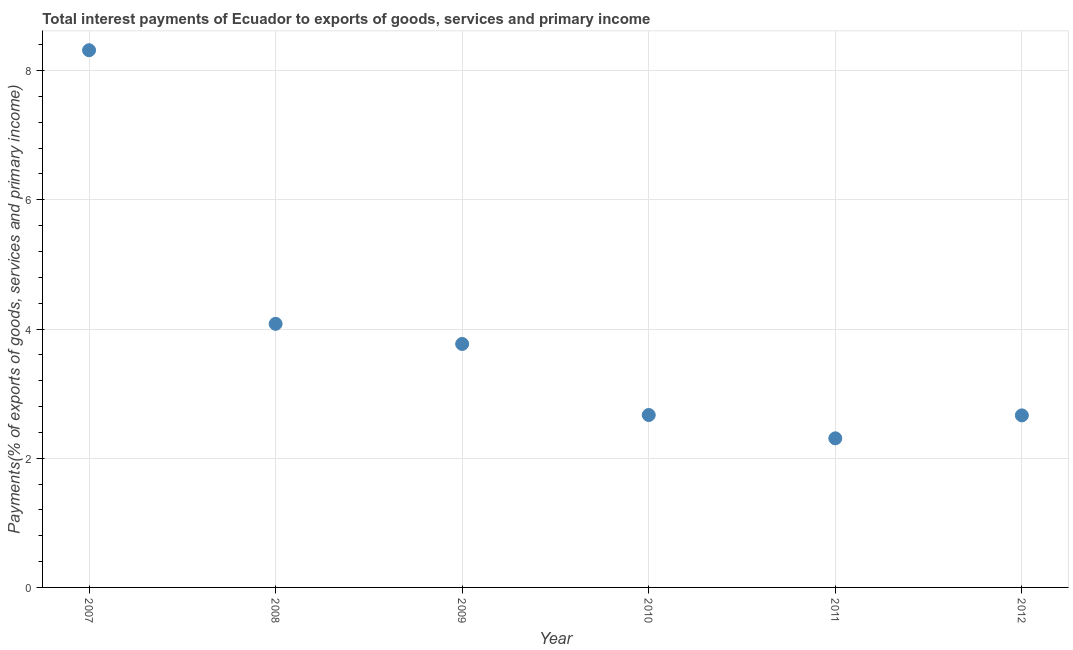What is the total interest payments on external debt in 2012?
Provide a succinct answer. 2.66. Across all years, what is the maximum total interest payments on external debt?
Keep it short and to the point. 8.32. Across all years, what is the minimum total interest payments on external debt?
Provide a succinct answer. 2.31. What is the sum of the total interest payments on external debt?
Keep it short and to the point. 23.8. What is the difference between the total interest payments on external debt in 2007 and 2008?
Your response must be concise. 4.23. What is the average total interest payments on external debt per year?
Offer a terse response. 3.97. What is the median total interest payments on external debt?
Make the answer very short. 3.22. Do a majority of the years between 2009 and 2008 (inclusive) have total interest payments on external debt greater than 7.6 %?
Provide a short and direct response. No. What is the ratio of the total interest payments on external debt in 2008 to that in 2010?
Give a very brief answer. 1.53. Is the total interest payments on external debt in 2009 less than that in 2012?
Make the answer very short. No. What is the difference between the highest and the second highest total interest payments on external debt?
Provide a succinct answer. 4.23. What is the difference between the highest and the lowest total interest payments on external debt?
Offer a terse response. 6.01. Does the total interest payments on external debt monotonically increase over the years?
Make the answer very short. No. What is the difference between two consecutive major ticks on the Y-axis?
Your answer should be very brief. 2. Does the graph contain any zero values?
Ensure brevity in your answer.  No. What is the title of the graph?
Your answer should be compact. Total interest payments of Ecuador to exports of goods, services and primary income. What is the label or title of the Y-axis?
Offer a very short reply. Payments(% of exports of goods, services and primary income). What is the Payments(% of exports of goods, services and primary income) in 2007?
Offer a terse response. 8.32. What is the Payments(% of exports of goods, services and primary income) in 2008?
Your answer should be very brief. 4.08. What is the Payments(% of exports of goods, services and primary income) in 2009?
Keep it short and to the point. 3.77. What is the Payments(% of exports of goods, services and primary income) in 2010?
Offer a very short reply. 2.67. What is the Payments(% of exports of goods, services and primary income) in 2011?
Offer a terse response. 2.31. What is the Payments(% of exports of goods, services and primary income) in 2012?
Ensure brevity in your answer.  2.66. What is the difference between the Payments(% of exports of goods, services and primary income) in 2007 and 2008?
Make the answer very short. 4.23. What is the difference between the Payments(% of exports of goods, services and primary income) in 2007 and 2009?
Your response must be concise. 4.55. What is the difference between the Payments(% of exports of goods, services and primary income) in 2007 and 2010?
Keep it short and to the point. 5.65. What is the difference between the Payments(% of exports of goods, services and primary income) in 2007 and 2011?
Keep it short and to the point. 6.01. What is the difference between the Payments(% of exports of goods, services and primary income) in 2007 and 2012?
Give a very brief answer. 5.65. What is the difference between the Payments(% of exports of goods, services and primary income) in 2008 and 2009?
Provide a succinct answer. 0.31. What is the difference between the Payments(% of exports of goods, services and primary income) in 2008 and 2010?
Your answer should be very brief. 1.41. What is the difference between the Payments(% of exports of goods, services and primary income) in 2008 and 2011?
Offer a terse response. 1.77. What is the difference between the Payments(% of exports of goods, services and primary income) in 2008 and 2012?
Provide a succinct answer. 1.42. What is the difference between the Payments(% of exports of goods, services and primary income) in 2009 and 2010?
Make the answer very short. 1.1. What is the difference between the Payments(% of exports of goods, services and primary income) in 2009 and 2011?
Your answer should be very brief. 1.46. What is the difference between the Payments(% of exports of goods, services and primary income) in 2009 and 2012?
Provide a short and direct response. 1.11. What is the difference between the Payments(% of exports of goods, services and primary income) in 2010 and 2011?
Give a very brief answer. 0.36. What is the difference between the Payments(% of exports of goods, services and primary income) in 2010 and 2012?
Your answer should be very brief. 0.01. What is the difference between the Payments(% of exports of goods, services and primary income) in 2011 and 2012?
Offer a very short reply. -0.36. What is the ratio of the Payments(% of exports of goods, services and primary income) in 2007 to that in 2008?
Give a very brief answer. 2.04. What is the ratio of the Payments(% of exports of goods, services and primary income) in 2007 to that in 2009?
Offer a very short reply. 2.21. What is the ratio of the Payments(% of exports of goods, services and primary income) in 2007 to that in 2010?
Give a very brief answer. 3.12. What is the ratio of the Payments(% of exports of goods, services and primary income) in 2007 to that in 2011?
Your response must be concise. 3.6. What is the ratio of the Payments(% of exports of goods, services and primary income) in 2007 to that in 2012?
Your response must be concise. 3.12. What is the ratio of the Payments(% of exports of goods, services and primary income) in 2008 to that in 2009?
Offer a very short reply. 1.08. What is the ratio of the Payments(% of exports of goods, services and primary income) in 2008 to that in 2010?
Provide a short and direct response. 1.53. What is the ratio of the Payments(% of exports of goods, services and primary income) in 2008 to that in 2011?
Your answer should be compact. 1.77. What is the ratio of the Payments(% of exports of goods, services and primary income) in 2008 to that in 2012?
Provide a succinct answer. 1.53. What is the ratio of the Payments(% of exports of goods, services and primary income) in 2009 to that in 2010?
Your answer should be very brief. 1.41. What is the ratio of the Payments(% of exports of goods, services and primary income) in 2009 to that in 2011?
Offer a very short reply. 1.63. What is the ratio of the Payments(% of exports of goods, services and primary income) in 2009 to that in 2012?
Provide a short and direct response. 1.42. What is the ratio of the Payments(% of exports of goods, services and primary income) in 2010 to that in 2011?
Make the answer very short. 1.16. What is the ratio of the Payments(% of exports of goods, services and primary income) in 2010 to that in 2012?
Keep it short and to the point. 1. What is the ratio of the Payments(% of exports of goods, services and primary income) in 2011 to that in 2012?
Your answer should be compact. 0.87. 